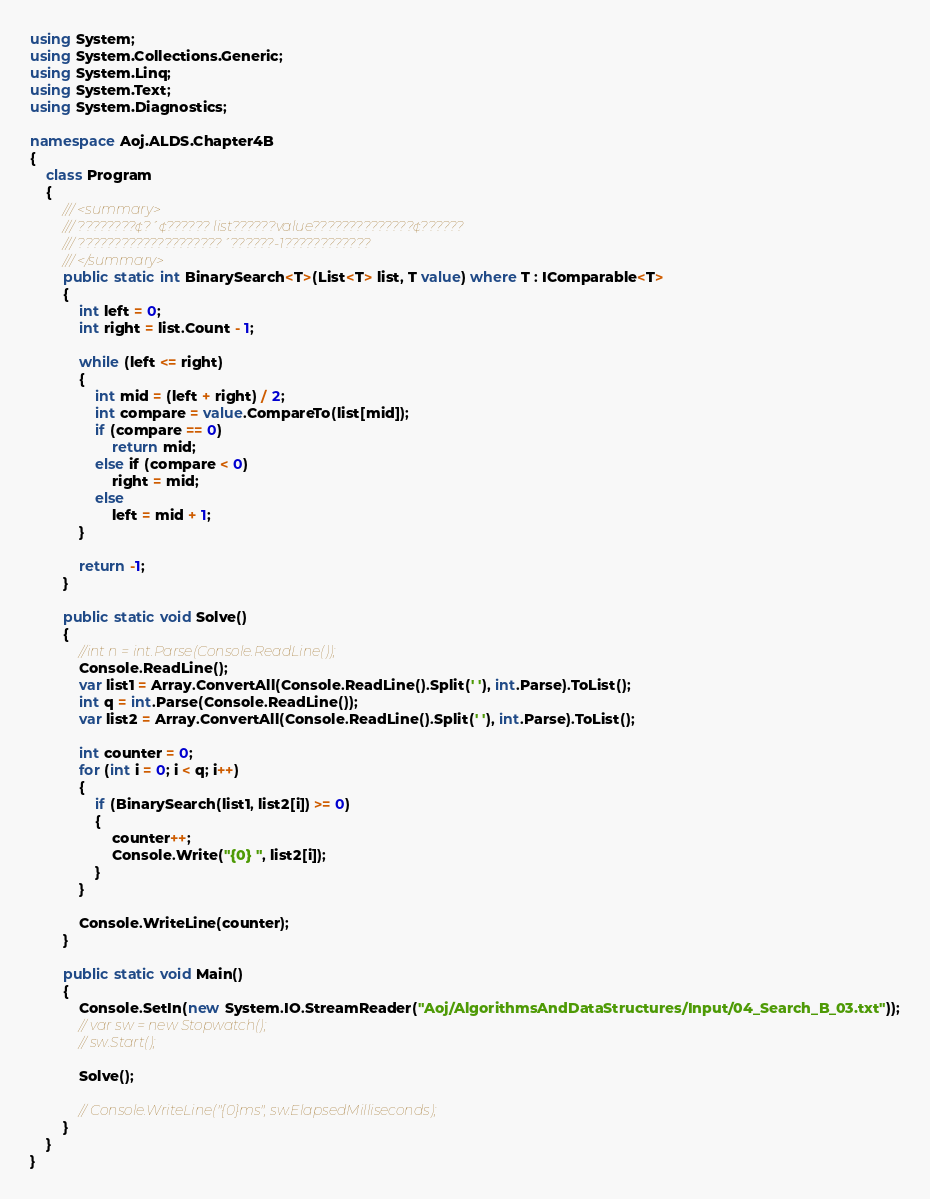<code> <loc_0><loc_0><loc_500><loc_500><_C#_>using System;
using System.Collections.Generic;
using System.Linq;
using System.Text;
using System.Diagnostics;

namespace Aoj.ALDS.Chapter4B
{
    class Program
    {
        /// <summary>
        /// ????????¢?´¢?????? list??????value??????????????¢??????
        /// ????????????????????´??????-1????????????
        /// </summary>
        public static int BinarySearch<T>(List<T> list, T value) where T : IComparable<T>
        {
            int left = 0;
            int right = list.Count - 1;

            while (left <= right)
            {
                int mid = (left + right) / 2;
                int compare = value.CompareTo(list[mid]);
                if (compare == 0)
                    return mid;
                else if (compare < 0)
                    right = mid;
                else
                    left = mid + 1;
            }

            return -1;
        }

        public static void Solve()
        {
            //int n = int.Parse(Console.ReadLine());
            Console.ReadLine();
            var list1 = Array.ConvertAll(Console.ReadLine().Split(' '), int.Parse).ToList();
            int q = int.Parse(Console.ReadLine());
            var list2 = Array.ConvertAll(Console.ReadLine().Split(' '), int.Parse).ToList();

            int counter = 0;
            for (int i = 0; i < q; i++)
            {
                if (BinarySearch(list1, list2[i]) >= 0)
                {
                    counter++;
                    Console.Write("{0} ", list2[i]);
                }
            }

            Console.WriteLine(counter);
        }

        public static void Main()
        {
            Console.SetIn(new System.IO.StreamReader("Aoj/AlgorithmsAndDataStructures/Input/04_Search_B_03.txt"));
            // var sw = new Stopwatch();
            // sw.Start();

            Solve();

            // Console.WriteLine("{0}ms", sw.ElapsedMilliseconds);
        }
    }
}</code> 